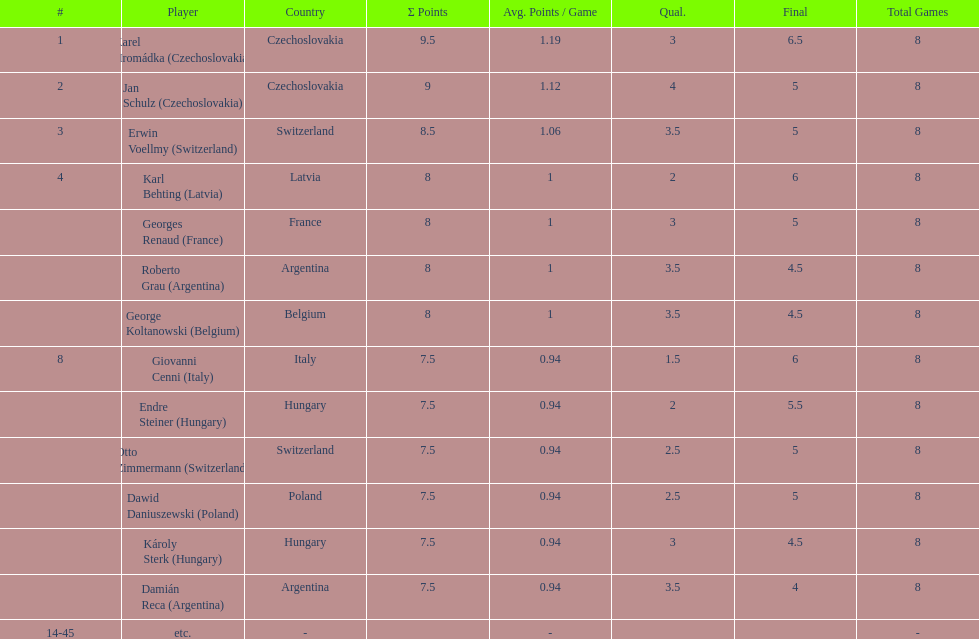Did the two competitors from hungary get more or less combined points than the two competitors from argentina? Less. 